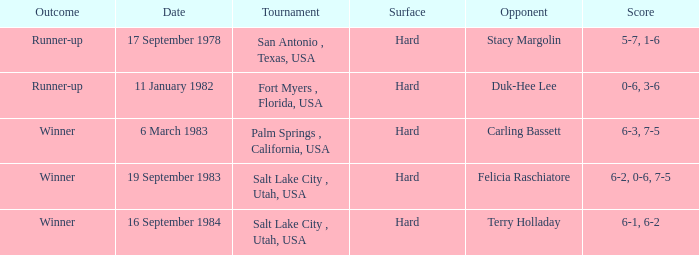Who was the rival in the contest where the finish was runner-up and the score was 5-7, 1-6? Stacy Margolin. 